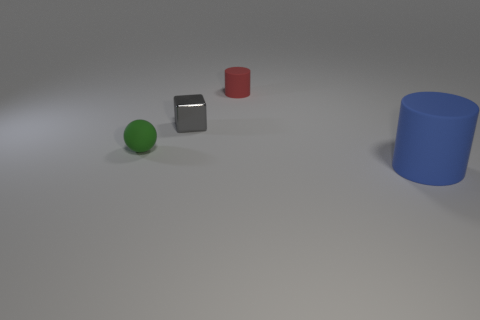Add 4 small shiny objects. How many objects exist? 8 Subtract all balls. How many objects are left? 3 Subtract 0 yellow spheres. How many objects are left? 4 Subtract all big gray balls. Subtract all large blue things. How many objects are left? 3 Add 2 green rubber objects. How many green rubber objects are left? 3 Add 1 shiny cubes. How many shiny cubes exist? 2 